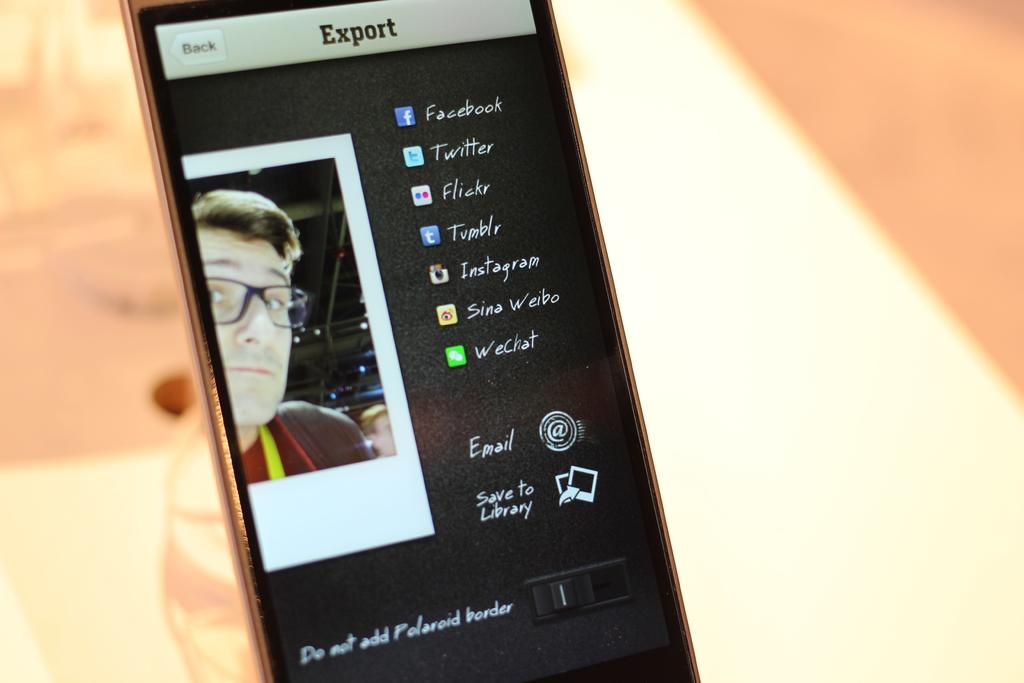What social media site can you export to?
Make the answer very short. Facebook. 